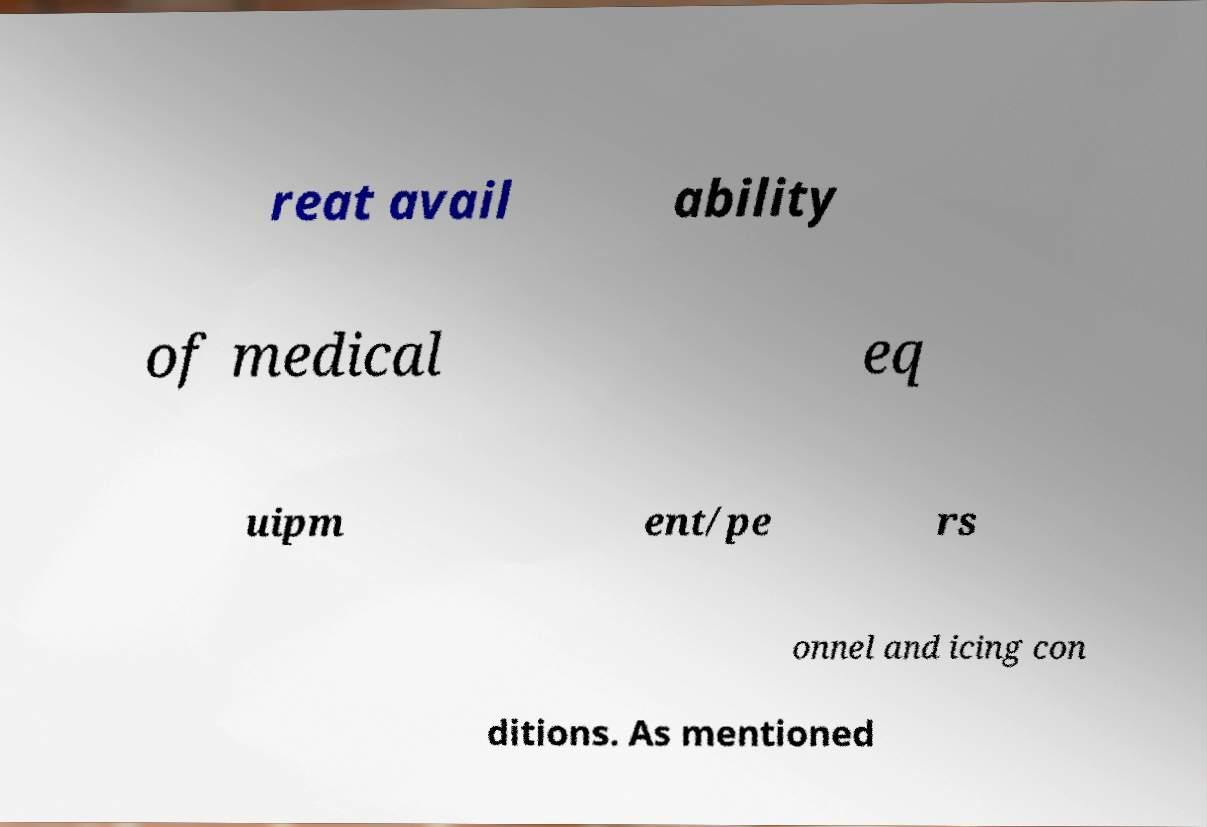Can you accurately transcribe the text from the provided image for me? reat avail ability of medical eq uipm ent/pe rs onnel and icing con ditions. As mentioned 